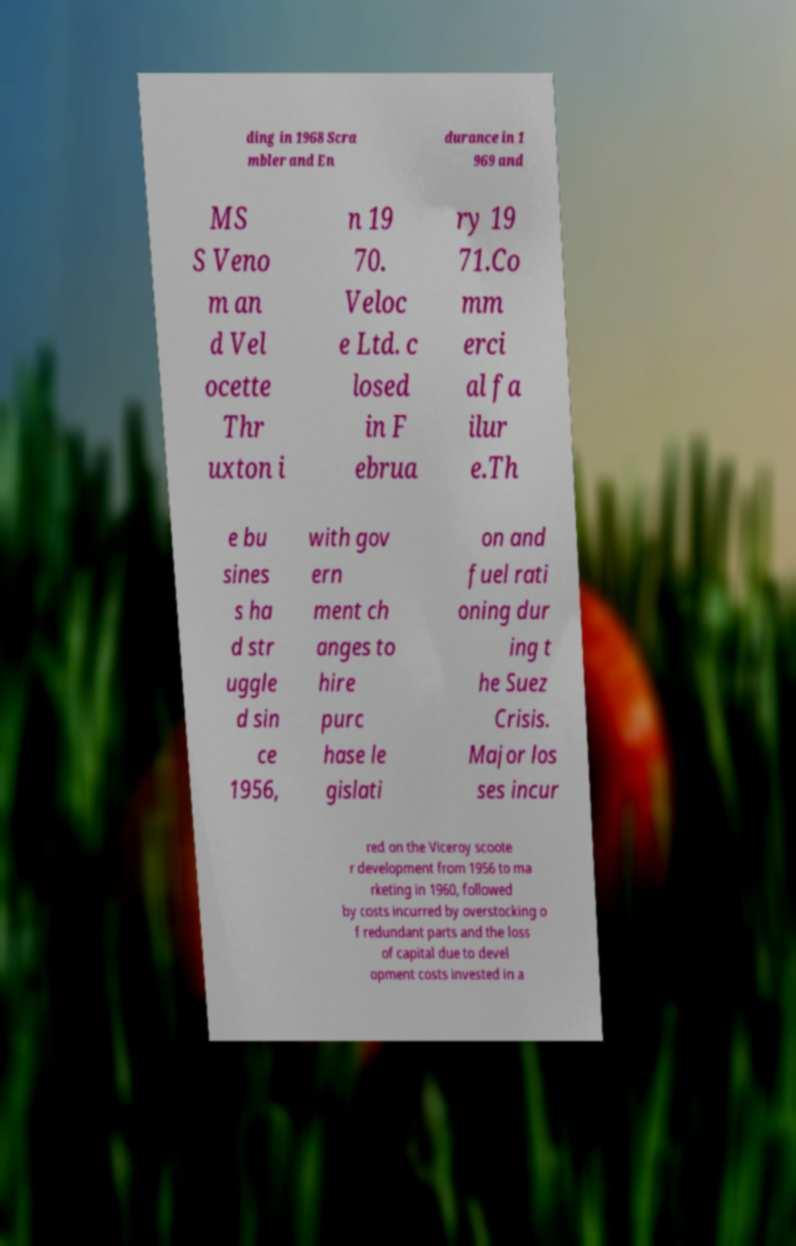Please identify and transcribe the text found in this image. ding in 1968 Scra mbler and En durance in 1 969 and MS S Veno m an d Vel ocette Thr uxton i n 19 70. Veloc e Ltd. c losed in F ebrua ry 19 71.Co mm erci al fa ilur e.Th e bu sines s ha d str uggle d sin ce 1956, with gov ern ment ch anges to hire purc hase le gislati on and fuel rati oning dur ing t he Suez Crisis. Major los ses incur red on the Viceroy scoote r development from 1956 to ma rketing in 1960, followed by costs incurred by overstocking o f redundant parts and the loss of capital due to devel opment costs invested in a 